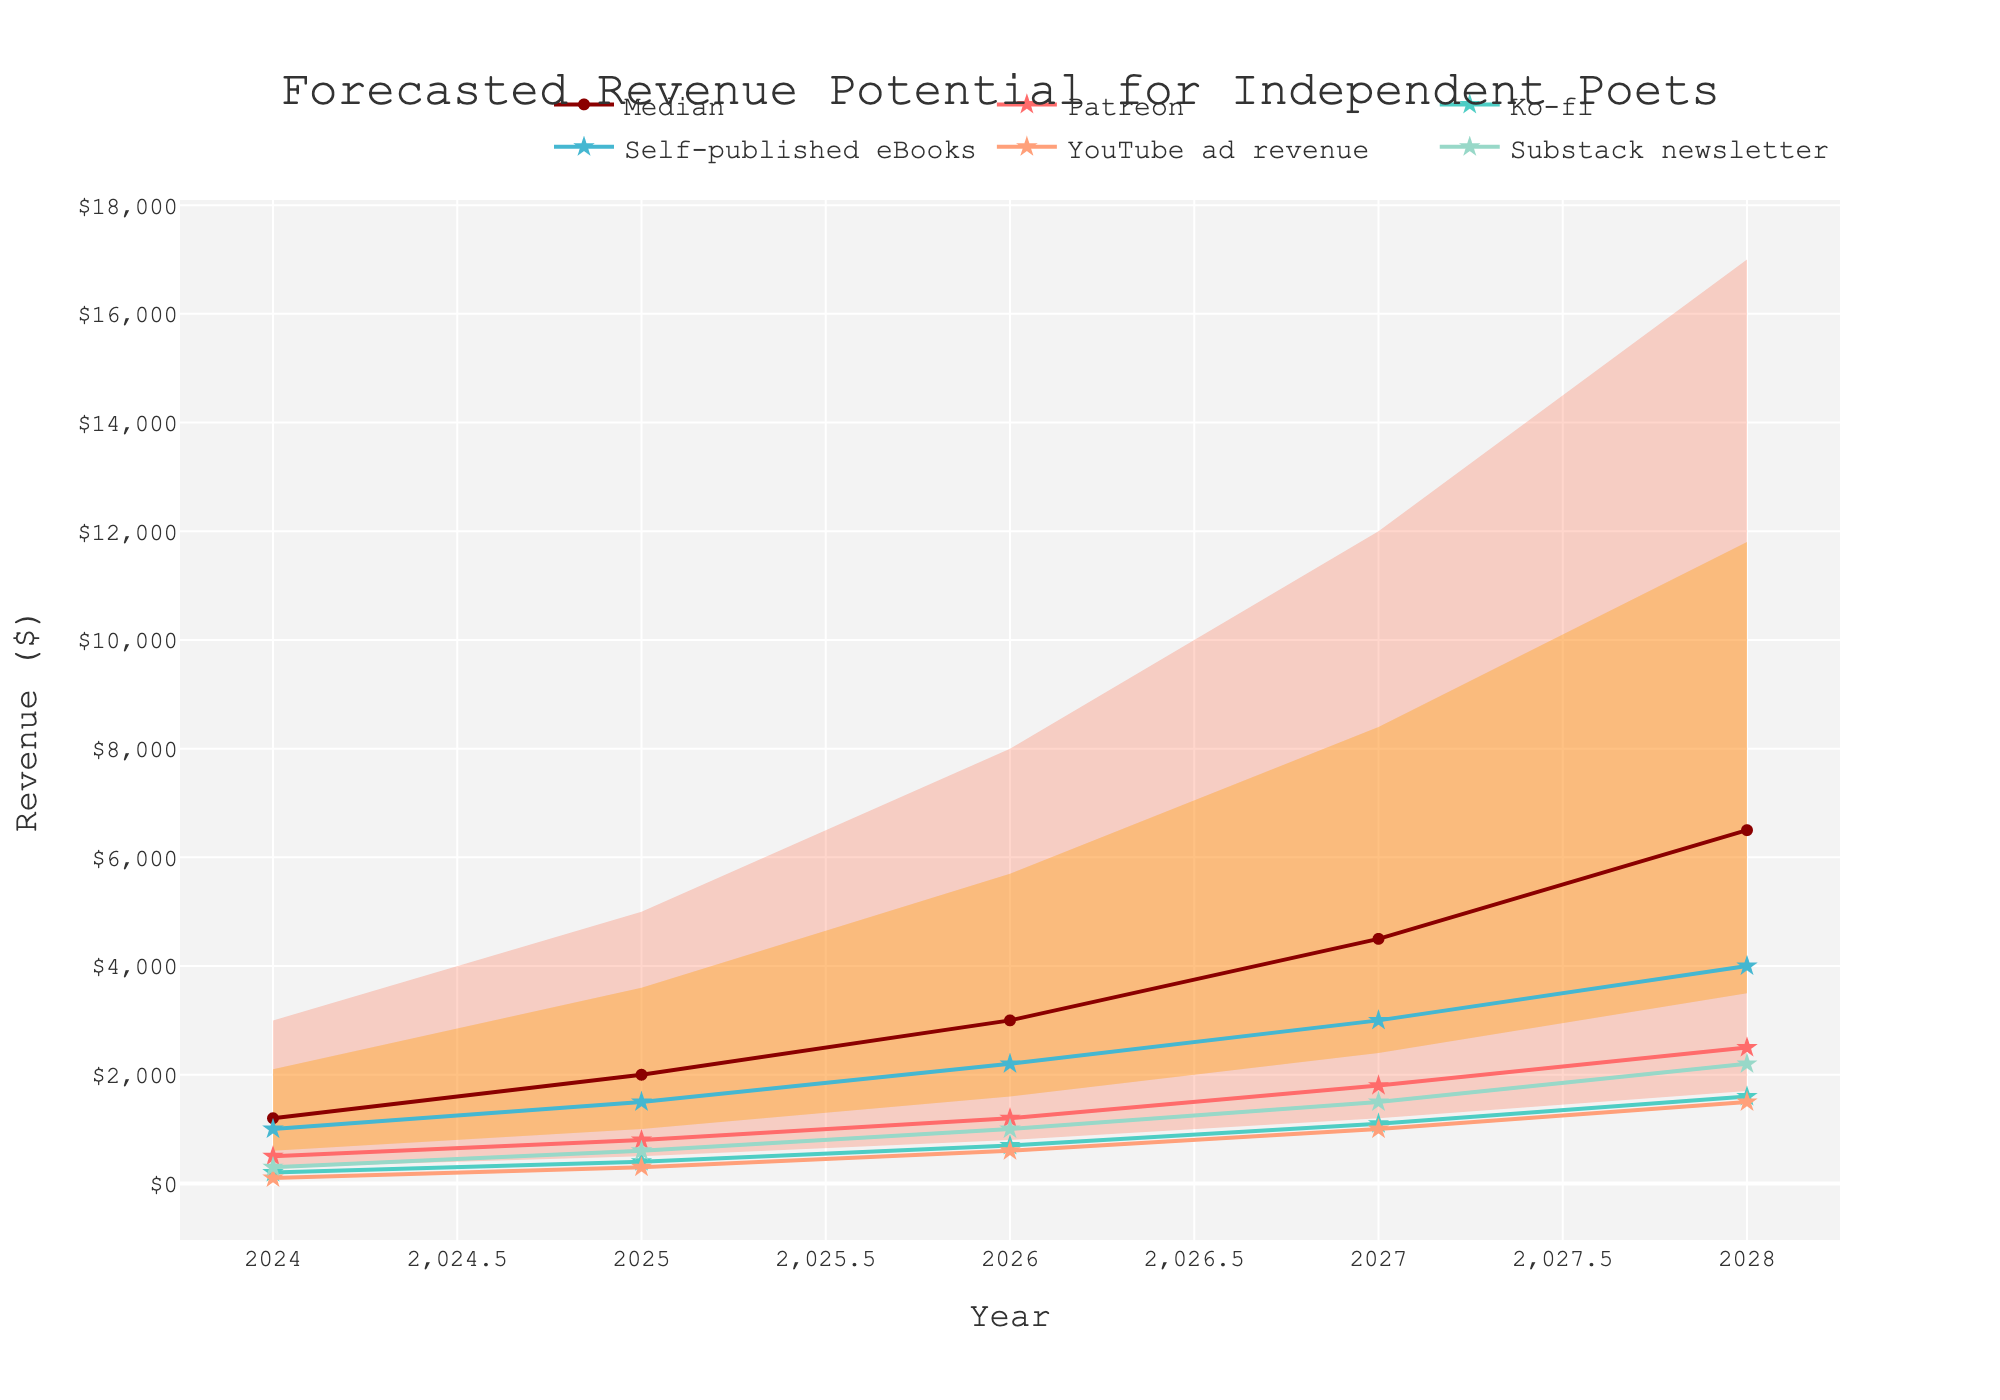What's the title of the figure? The title is usually displayed at the top of the figure. In this case, it is prominently shown as "Forecasted Revenue Potential for Independent Poets".
Answer: Forecasted Revenue Potential for Independent Poets How much revenue is projected for Patreon in 2024? Look for the line representing Patreon and find the value corresponding to the year 2024. According to the data, it is $500.
Answer: $500 What is the median forecasted revenue in 2027? Locate the median value line on the chart for the year 2027. Reference the data where the median value is listed for each year. It shows $4500 for 2027.
Answer: $4500 Which monetization method shows the highest revenue by 2028? Observe the end points of all lines representing different methods in the year 2028. Self-published eBooks has the highest point, which is $4000.
Answer: Self-published eBooks How does the 75th percentile revenue change from 2024 to 2028? Refer to the 75th percentile values for each year between 2024 and 2028. In 2024, it's $2100, and in 2028, it's $11800. The change is calculated by subtracting the value in 2024 from that in 2028: $11800 - $2100 = $9700.
Answer: $9700 Which year shows the smallest gap between the 10th and 90th percentile revenues? Find the differences between the 10th and 90th percentiles for each year. Compare these gaps across all years. 2024 shows the smallest gap: $3000 (90th percentile) - $300 (10th percentile) = $2700.
Answer: 2024 What is the projected revenue from YouTube ad revenue in 2026? Trace the line for YouTube ad revenue to the year 2026. The corresponding value is $600.
Answer: $600 By what percentage does the median forecasted revenue increase from 2024 to 2025? Calculate the percentage increase from the median value in 2024 to that in 2025. The median values are $1200 (2024) and $2000 (2025). The percentage increase is computed as (($2000 - $1200)/$1200) * 100%.
Answer: 66.67% How much is the forecasted revenue from Substack newsletter expected to be in 2027? Locate the point on the line representing Substack newsletter for the year 2027. The expected revenue is $1500.
Answer: $1500 Which monetization method experiences the most significant absolute increase in projected revenue from 2024 to 2028? Calculate the absolute increases for each method by finding the revenue difference between 2024 and 2028 for each. Self-published eBooks increases from $1000 to $4000, which is an increase of $3000, the highest among the methods.
Answer: Self-published eBooks 